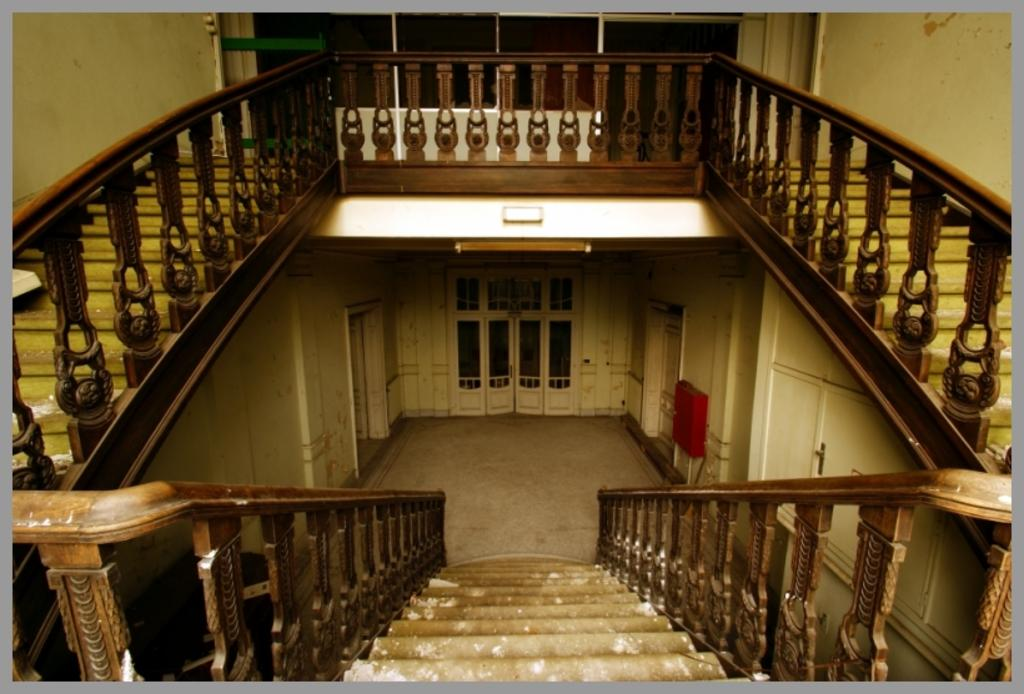What type of setting is depicted in the image? The image shows an inside view of a building. Can you describe any architectural features visible in the image? Yes, there are steps visible in the image. What type of barrier is present in the image? There is fencing present in the image. What type of structure is visible in the image? Walls are visible in the image. How many dimes can be seen on the face of the person in the image? There is no person or dimes present in the image. What type of journey is being depicted in the image? The image does not depict a journey; it shows an inside view of a building. 